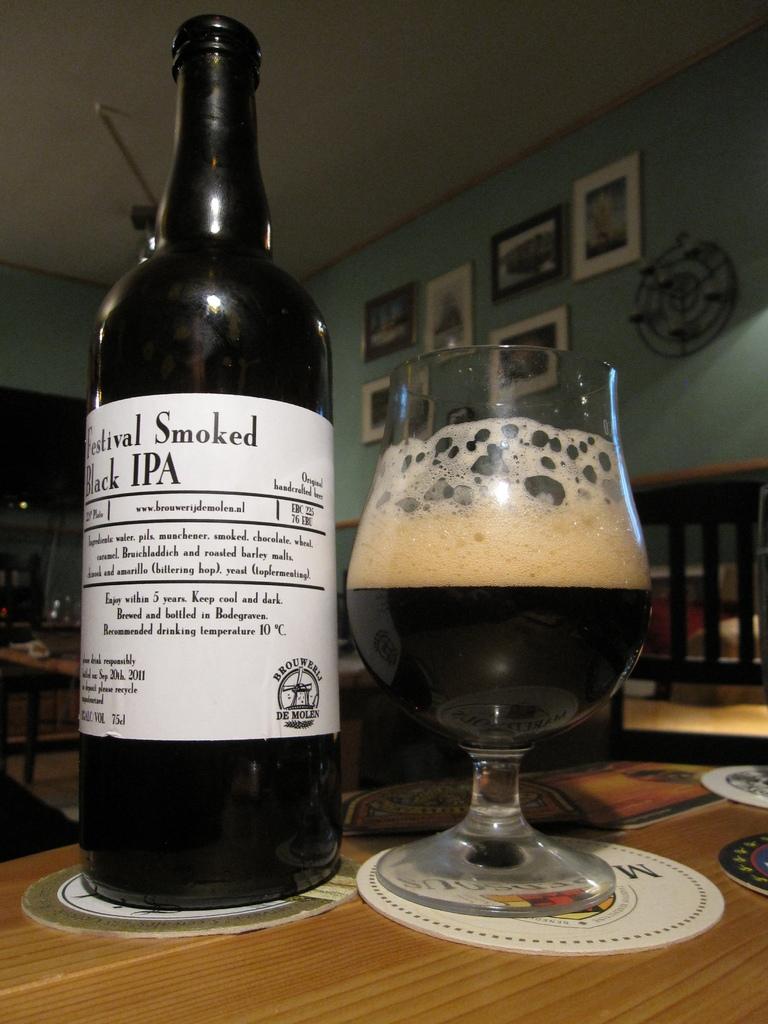What word is written above ipa?
Make the answer very short. Smoked. 